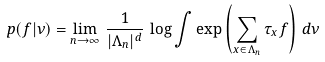<formula> <loc_0><loc_0><loc_500><loc_500>p ( f | \nu ) = \lim _ { n \to \infty } \, \frac { 1 } { | \Lambda _ { n } | ^ { d } } \, \log \int \exp \left ( \sum _ { x \in \Lambda _ { n } } \tau _ { x } f \right ) \, d \nu</formula> 